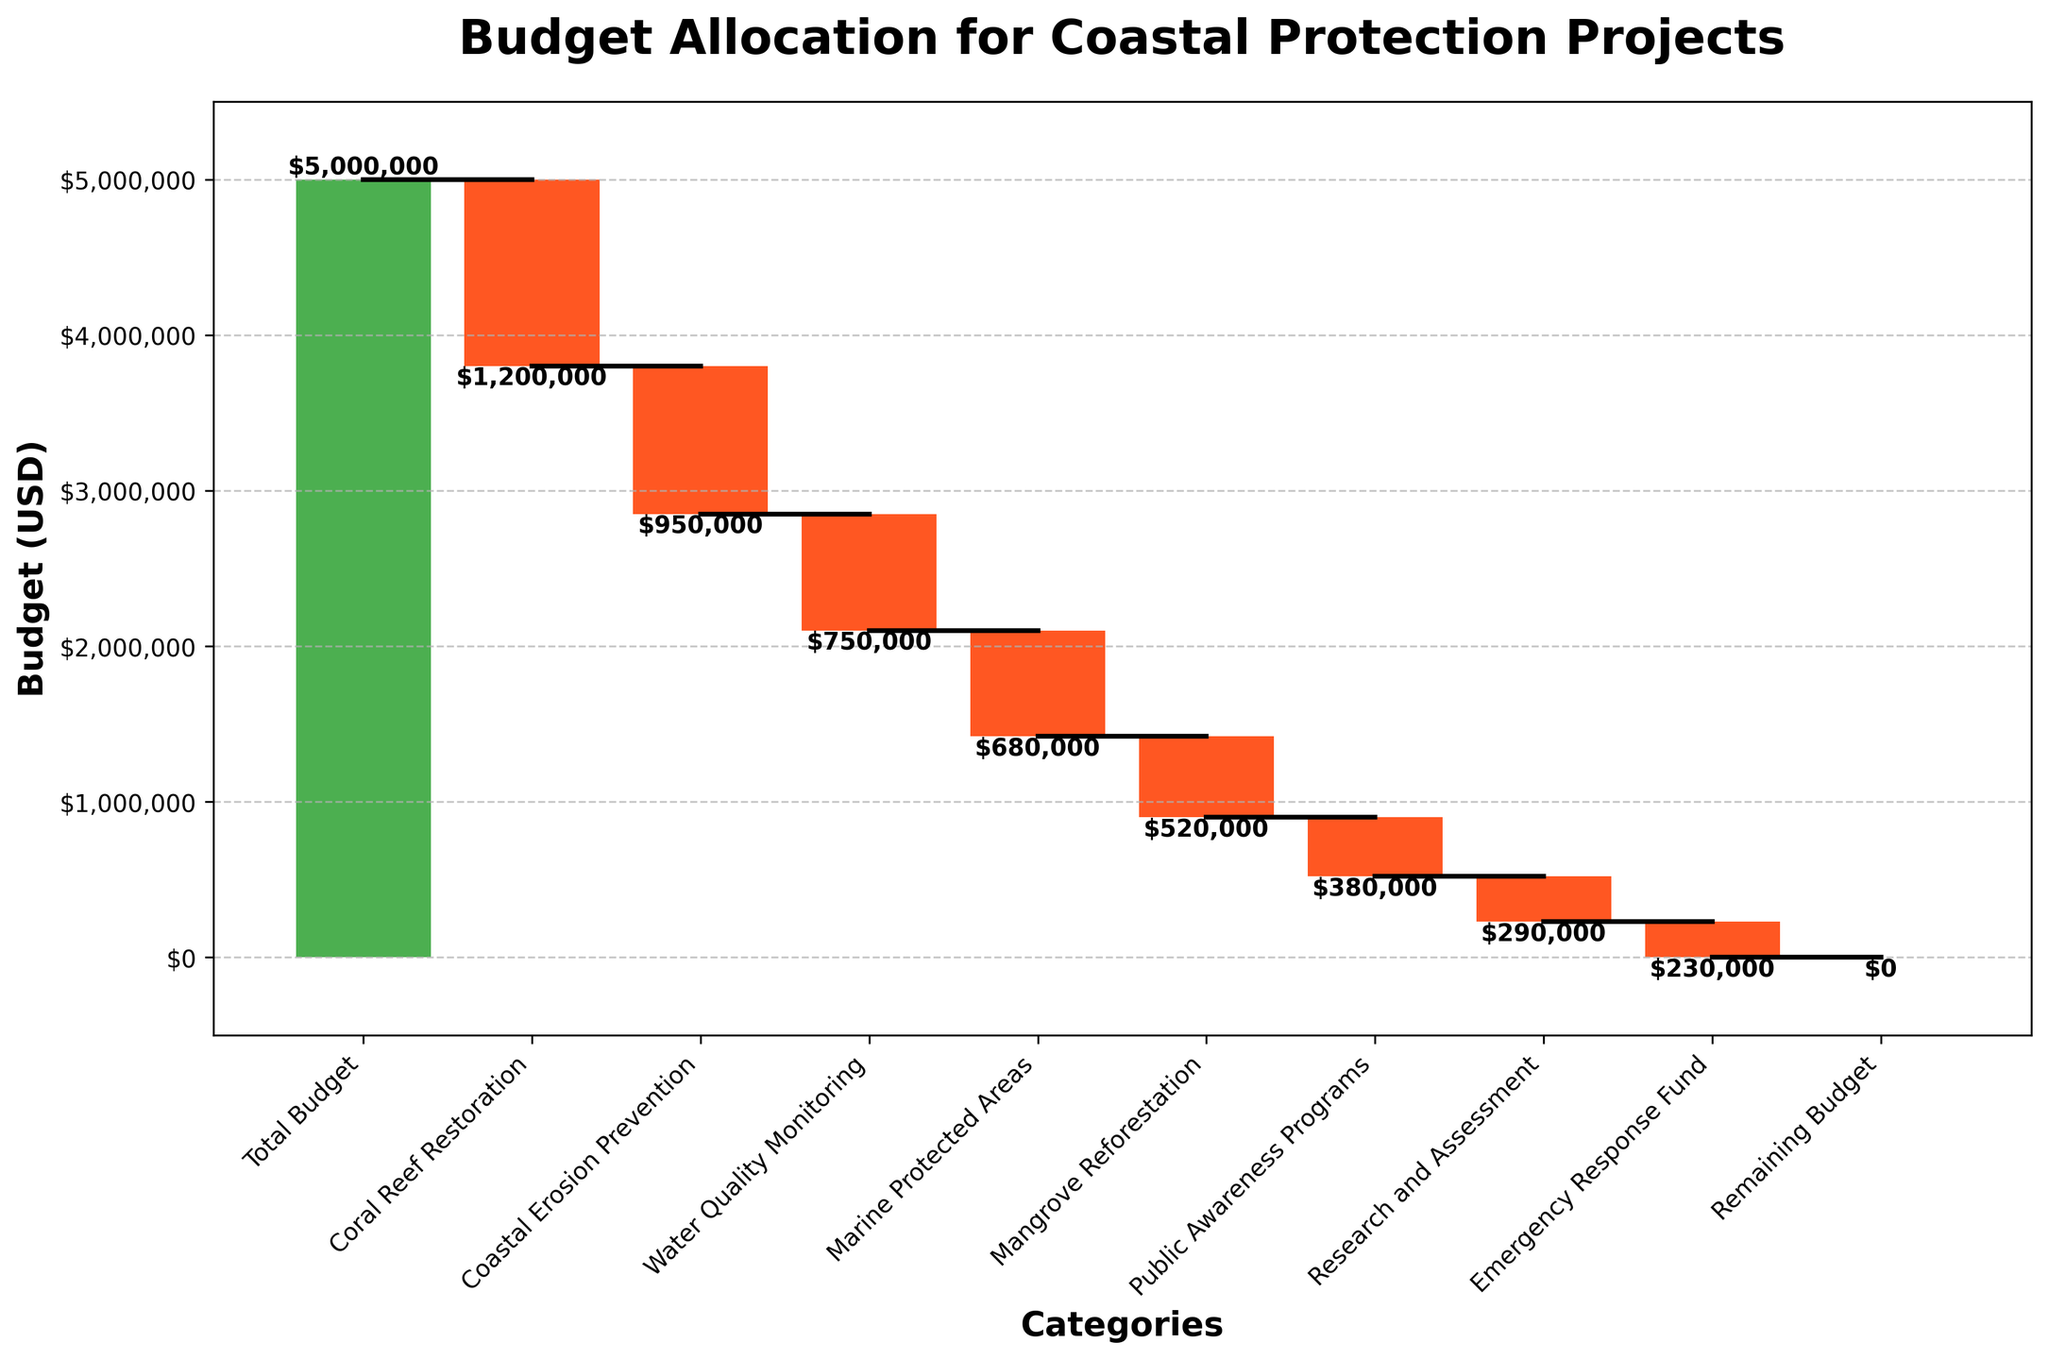What’s the value for the Coral Reef Restoration initiative? The value is shown on the figure as a bar labeled "Coral Reef Restoration" with a value of –1,200,000.
Answer: –1,200,000 What color represents the Coastal Erosion Prevention bar? In the figure, the colors represent the type of values: positive values are green and negative values are red. The Coastal Erosion Prevention bar is colored red, indicating it has a negative value.
Answer: Red How much money was allocated for Public Awareness Programs? The waterfall chart displays the allocation for Public Awareness Programs in a bar with a negative value of –380,000.
Answer: –380,000 Which initiative has the smallest budget allocation? By examining the heights of the bars, the Research and Assessment bar is the shortest, representing the smallest budget allocation of –290,000.
Answer: Research and Assessment What’s the total budget before any allocations? The figure starts with the "Total Budget" bar, which has a value of 5,000,000.
Answer: 5,000,000 What’s the combined budget for Marine Protected Areas and Mangrove Reforestation? The values for Marine Protected Areas and Mangrove Reforestation are –680,000 and –520,000, respectively. Summing them gives –680,000 + –520,000 = –1,200,000.
Answer: –1,200,000 Which initiative has a higher budget allocation, Water Quality Monitoring or Marine Protected Areas? Comparing the heights of the two bars, Water Quality Monitoring (–750,000) has a higher budget allocation than Marine Protected Areas (–680,000).
Answer: Water Quality Monitoring How much budget remains after all the allocations? After all the allocations, the "Remaining Budget" bar is at the end, showing a remaining budget of 0.
Answer: 0 What’s the total budget allocated for all initiatives? Summing up the values of all the allocation bars:
Coral Reef Restoration (–1,200,000)
Coastal Erosion Prevention (–950,000)
Water Quality Monitoring (–750,000)
Marine Protected Areas (–680,000)
Mangrove Reforestation (–520,000)
Public Awareness Programs (–380,000)
Research and Assessment (–290,000)
Emergency Response Fund (–230,000)
The total is –5,000,000.
Answer: –5,000,000 